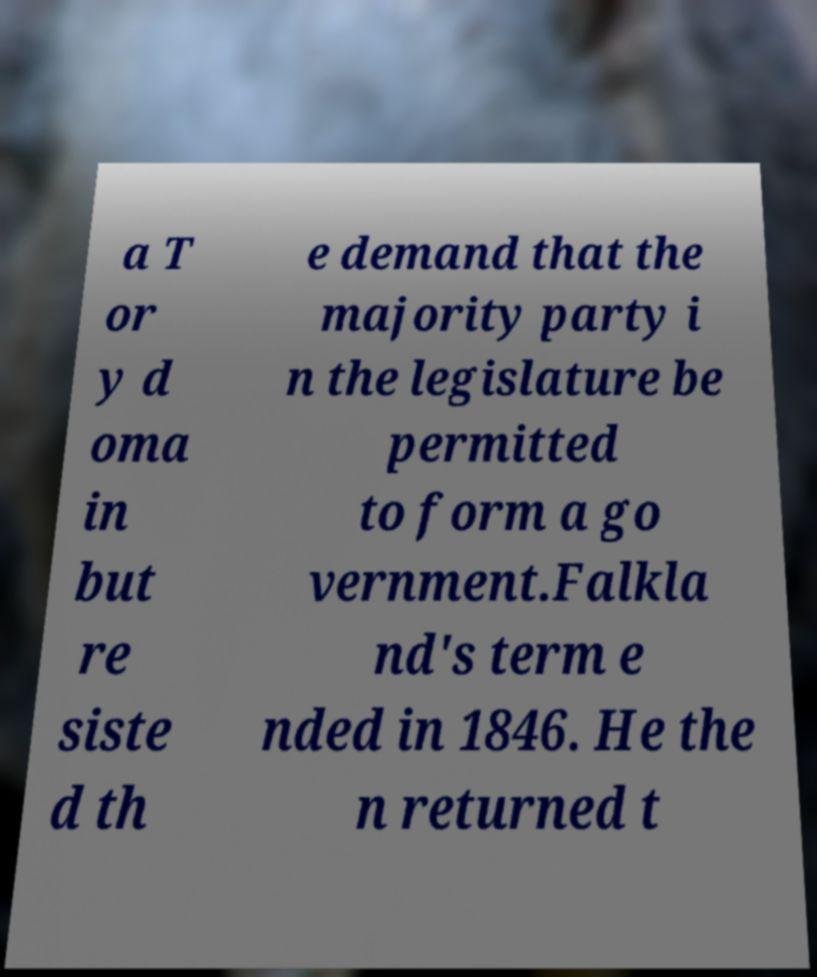What messages or text are displayed in this image? I need them in a readable, typed format. a T or y d oma in but re siste d th e demand that the majority party i n the legislature be permitted to form a go vernment.Falkla nd's term e nded in 1846. He the n returned t 